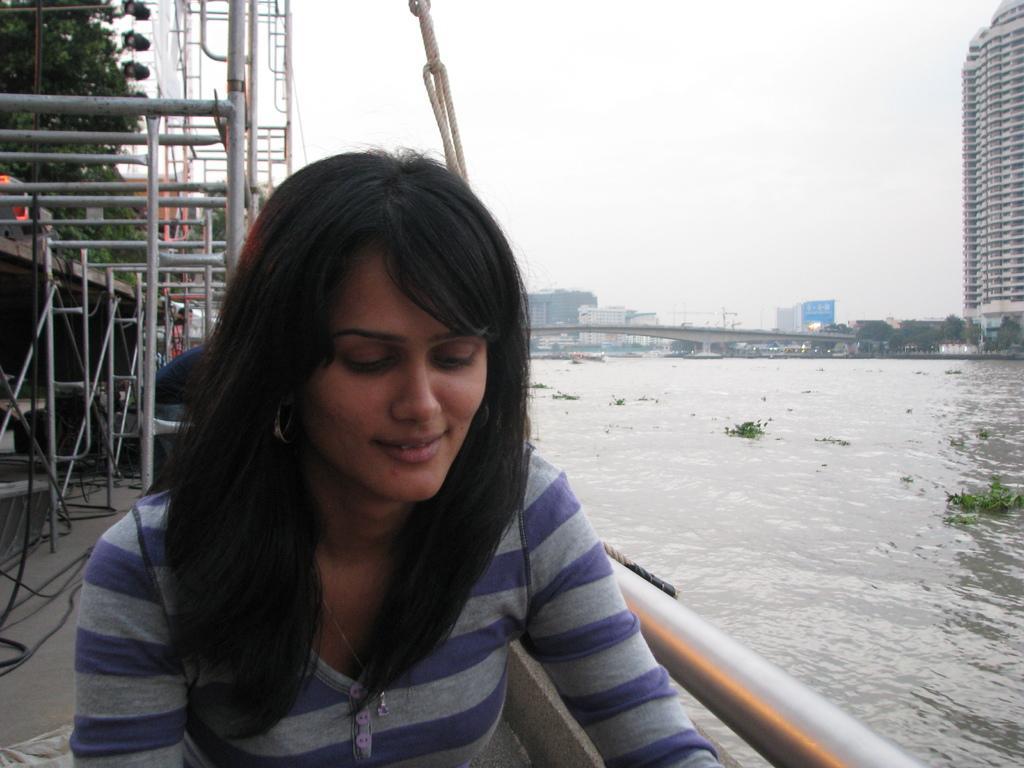In one or two sentences, can you explain what this image depicts? This is an outside view. Here I can see a woman wearing a t-shirt, smiling and looking at the downwards. Beside her there is a metal rod. On the right side there is a river. In the background, I can see many buildings. On the left side, I can see few metals stands and some trees. At the top of the image I can see the sky. 